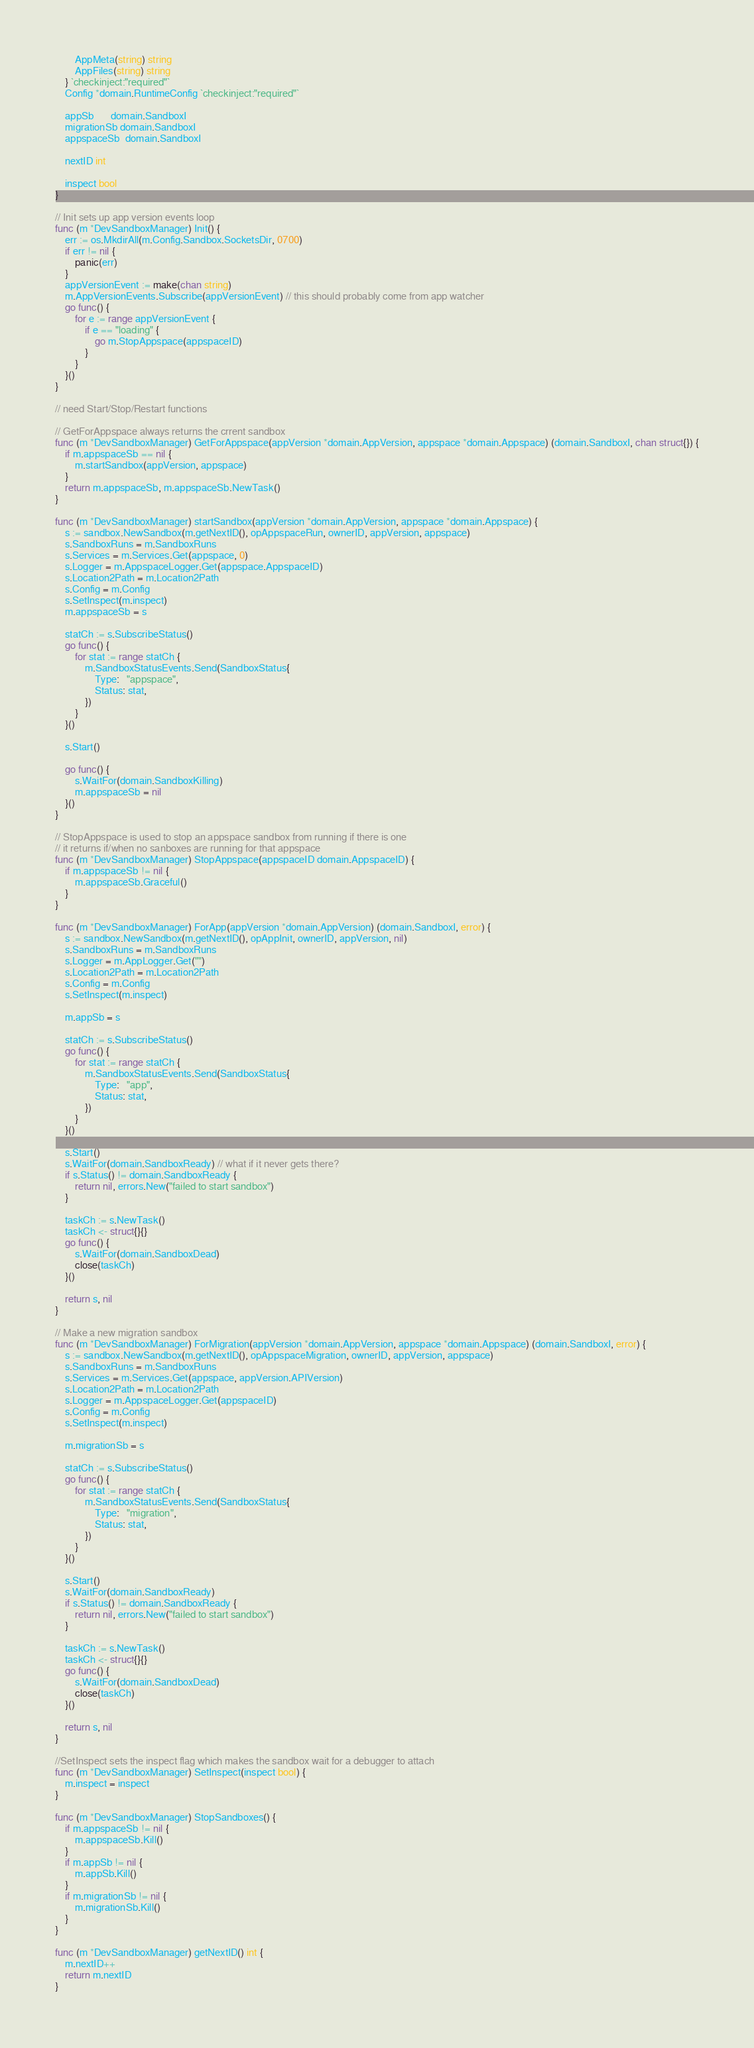Convert code to text. <code><loc_0><loc_0><loc_500><loc_500><_Go_>		AppMeta(string) string
		AppFiles(string) string
	} `checkinject:"required"`
	Config *domain.RuntimeConfig `checkinject:"required"`

	appSb       domain.SandboxI
	migrationSb domain.SandboxI
	appspaceSb  domain.SandboxI

	nextID int

	inspect bool
}

// Init sets up app version events loop
func (m *DevSandboxManager) Init() {
	err := os.MkdirAll(m.Config.Sandbox.SocketsDir, 0700)
	if err != nil {
		panic(err)
	}
	appVersionEvent := make(chan string)
	m.AppVersionEvents.Subscribe(appVersionEvent) // this should probably come from app watcher
	go func() {
		for e := range appVersionEvent {
			if e == "loading" {
				go m.StopAppspace(appspaceID)
			}
		}
	}()
}

// need Start/Stop/Restart functions

// GetForAppspace always returns the crrent sandbox
func (m *DevSandboxManager) GetForAppspace(appVersion *domain.AppVersion, appspace *domain.Appspace) (domain.SandboxI, chan struct{}) {
	if m.appspaceSb == nil {
		m.startSandbox(appVersion, appspace)
	}
	return m.appspaceSb, m.appspaceSb.NewTask()
}

func (m *DevSandboxManager) startSandbox(appVersion *domain.AppVersion, appspace *domain.Appspace) {
	s := sandbox.NewSandbox(m.getNextID(), opAppspaceRun, ownerID, appVersion, appspace)
	s.SandboxRuns = m.SandboxRuns
	s.Services = m.Services.Get(appspace, 0)
	s.Logger = m.AppspaceLogger.Get(appspace.AppspaceID)
	s.Location2Path = m.Location2Path
	s.Config = m.Config
	s.SetInspect(m.inspect)
	m.appspaceSb = s

	statCh := s.SubscribeStatus()
	go func() {
		for stat := range statCh {
			m.SandboxStatusEvents.Send(SandboxStatus{
				Type:   "appspace",
				Status: stat,
			})
		}
	}()

	s.Start()

	go func() {
		s.WaitFor(domain.SandboxKilling)
		m.appspaceSb = nil
	}()
}

// StopAppspace is used to stop an appspace sandbox from running if there is one
// it returns if/when no sanboxes are running for that appspace
func (m *DevSandboxManager) StopAppspace(appspaceID domain.AppspaceID) {
	if m.appspaceSb != nil {
		m.appspaceSb.Graceful()
	}
}

func (m *DevSandboxManager) ForApp(appVersion *domain.AppVersion) (domain.SandboxI, error) {
	s := sandbox.NewSandbox(m.getNextID(), opAppInit, ownerID, appVersion, nil)
	s.SandboxRuns = m.SandboxRuns
	s.Logger = m.AppLogger.Get("")
	s.Location2Path = m.Location2Path
	s.Config = m.Config
	s.SetInspect(m.inspect)

	m.appSb = s

	statCh := s.SubscribeStatus()
	go func() {
		for stat := range statCh {
			m.SandboxStatusEvents.Send(SandboxStatus{
				Type:   "app",
				Status: stat,
			})
		}
	}()

	s.Start()
	s.WaitFor(domain.SandboxReady) // what if it never gets there?
	if s.Status() != domain.SandboxReady {
		return nil, errors.New("failed to start sandbox")
	}

	taskCh := s.NewTask()
	taskCh <- struct{}{}
	go func() {
		s.WaitFor(domain.SandboxDead)
		close(taskCh)
	}()

	return s, nil
}

// Make a new migration sandbox
func (m *DevSandboxManager) ForMigration(appVersion *domain.AppVersion, appspace *domain.Appspace) (domain.SandboxI, error) {
	s := sandbox.NewSandbox(m.getNextID(), opAppspaceMigration, ownerID, appVersion, appspace)
	s.SandboxRuns = m.SandboxRuns
	s.Services = m.Services.Get(appspace, appVersion.APIVersion)
	s.Location2Path = m.Location2Path
	s.Logger = m.AppspaceLogger.Get(appspaceID)
	s.Config = m.Config
	s.SetInspect(m.inspect)

	m.migrationSb = s

	statCh := s.SubscribeStatus()
	go func() {
		for stat := range statCh {
			m.SandboxStatusEvents.Send(SandboxStatus{
				Type:   "migration",
				Status: stat,
			})
		}
	}()

	s.Start()
	s.WaitFor(domain.SandboxReady)
	if s.Status() != domain.SandboxReady {
		return nil, errors.New("failed to start sandbox")
	}

	taskCh := s.NewTask()
	taskCh <- struct{}{}
	go func() {
		s.WaitFor(domain.SandboxDead)
		close(taskCh)
	}()

	return s, nil
}

//SetInspect sets the inspect flag which makes the sandbox wait for a debugger to attach
func (m *DevSandboxManager) SetInspect(inspect bool) {
	m.inspect = inspect
}

func (m *DevSandboxManager) StopSandboxes() {
	if m.appspaceSb != nil {
		m.appspaceSb.Kill()
	}
	if m.appSb != nil {
		m.appSb.Kill()
	}
	if m.migrationSb != nil {
		m.migrationSb.Kill()
	}
}

func (m *DevSandboxManager) getNextID() int {
	m.nextID++
	return m.nextID
}
</code> 